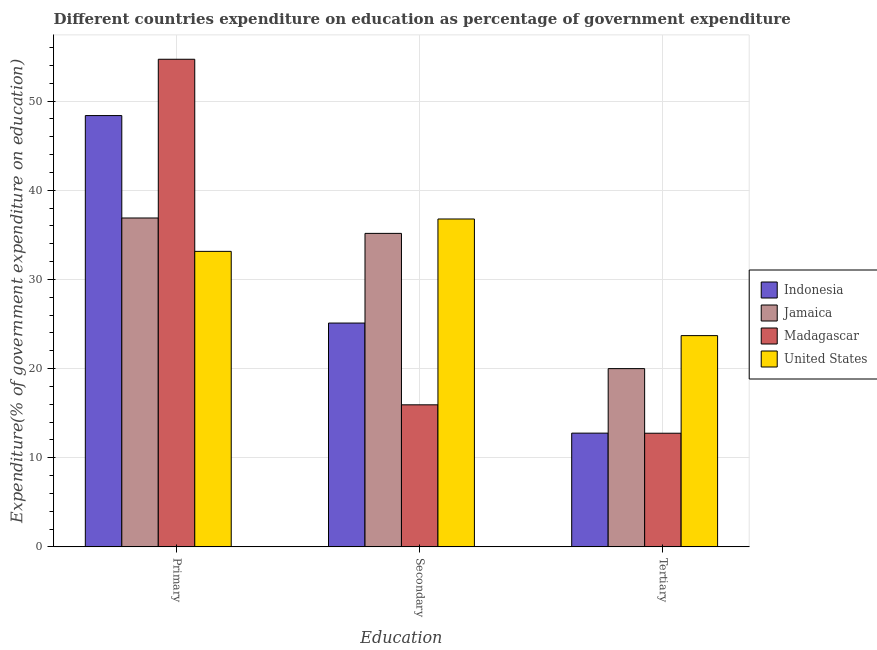How many different coloured bars are there?
Your response must be concise. 4. How many groups of bars are there?
Your answer should be compact. 3. Are the number of bars per tick equal to the number of legend labels?
Provide a succinct answer. Yes. Are the number of bars on each tick of the X-axis equal?
Provide a short and direct response. Yes. How many bars are there on the 1st tick from the left?
Provide a short and direct response. 4. What is the label of the 3rd group of bars from the left?
Offer a terse response. Tertiary. What is the expenditure on tertiary education in Jamaica?
Make the answer very short. 20. Across all countries, what is the maximum expenditure on primary education?
Offer a very short reply. 54.7. Across all countries, what is the minimum expenditure on primary education?
Provide a short and direct response. 33.15. In which country was the expenditure on tertiary education maximum?
Provide a short and direct response. United States. In which country was the expenditure on secondary education minimum?
Make the answer very short. Madagascar. What is the total expenditure on secondary education in the graph?
Ensure brevity in your answer.  112.99. What is the difference between the expenditure on primary education in Indonesia and that in Jamaica?
Your answer should be very brief. 11.49. What is the difference between the expenditure on tertiary education in Madagascar and the expenditure on primary education in United States?
Provide a short and direct response. -20.4. What is the average expenditure on tertiary education per country?
Your answer should be compact. 17.3. What is the difference between the expenditure on primary education and expenditure on secondary education in Indonesia?
Give a very brief answer. 23.28. In how many countries, is the expenditure on tertiary education greater than 22 %?
Offer a very short reply. 1. What is the ratio of the expenditure on primary education in Indonesia to that in United States?
Make the answer very short. 1.46. Is the expenditure on tertiary education in Madagascar less than that in Jamaica?
Offer a terse response. Yes. Is the difference between the expenditure on tertiary education in Jamaica and Madagascar greater than the difference between the expenditure on primary education in Jamaica and Madagascar?
Keep it short and to the point. Yes. What is the difference between the highest and the second highest expenditure on tertiary education?
Keep it short and to the point. 3.7. What is the difference between the highest and the lowest expenditure on primary education?
Your answer should be compact. 21.55. In how many countries, is the expenditure on primary education greater than the average expenditure on primary education taken over all countries?
Provide a short and direct response. 2. Is the sum of the expenditure on secondary education in Madagascar and United States greater than the maximum expenditure on primary education across all countries?
Offer a terse response. No. What does the 1st bar from the right in Secondary represents?
Make the answer very short. United States. Is it the case that in every country, the sum of the expenditure on primary education and expenditure on secondary education is greater than the expenditure on tertiary education?
Make the answer very short. Yes. How many bars are there?
Provide a short and direct response. 12. Are all the bars in the graph horizontal?
Provide a short and direct response. No. Where does the legend appear in the graph?
Your answer should be compact. Center right. How are the legend labels stacked?
Give a very brief answer. Vertical. What is the title of the graph?
Make the answer very short. Different countries expenditure on education as percentage of government expenditure. Does "Low & middle income" appear as one of the legend labels in the graph?
Your answer should be very brief. No. What is the label or title of the X-axis?
Your answer should be very brief. Education. What is the label or title of the Y-axis?
Offer a very short reply. Expenditure(% of government expenditure on education). What is the Expenditure(% of government expenditure on education) of Indonesia in Primary?
Make the answer very short. 48.38. What is the Expenditure(% of government expenditure on education) in Jamaica in Primary?
Your answer should be compact. 36.89. What is the Expenditure(% of government expenditure on education) in Madagascar in Primary?
Your answer should be very brief. 54.7. What is the Expenditure(% of government expenditure on education) of United States in Primary?
Provide a short and direct response. 33.15. What is the Expenditure(% of government expenditure on education) of Indonesia in Secondary?
Make the answer very short. 25.11. What is the Expenditure(% of government expenditure on education) of Jamaica in Secondary?
Keep it short and to the point. 35.17. What is the Expenditure(% of government expenditure on education) of Madagascar in Secondary?
Your answer should be compact. 15.93. What is the Expenditure(% of government expenditure on education) of United States in Secondary?
Make the answer very short. 36.78. What is the Expenditure(% of government expenditure on education) in Indonesia in Tertiary?
Your answer should be compact. 12.76. What is the Expenditure(% of government expenditure on education) of Jamaica in Tertiary?
Ensure brevity in your answer.  20. What is the Expenditure(% of government expenditure on education) of Madagascar in Tertiary?
Provide a succinct answer. 12.75. What is the Expenditure(% of government expenditure on education) in United States in Tertiary?
Make the answer very short. 23.7. Across all Education, what is the maximum Expenditure(% of government expenditure on education) of Indonesia?
Ensure brevity in your answer.  48.38. Across all Education, what is the maximum Expenditure(% of government expenditure on education) of Jamaica?
Give a very brief answer. 36.89. Across all Education, what is the maximum Expenditure(% of government expenditure on education) of Madagascar?
Keep it short and to the point. 54.7. Across all Education, what is the maximum Expenditure(% of government expenditure on education) in United States?
Offer a very short reply. 36.78. Across all Education, what is the minimum Expenditure(% of government expenditure on education) in Indonesia?
Keep it short and to the point. 12.76. Across all Education, what is the minimum Expenditure(% of government expenditure on education) in Jamaica?
Keep it short and to the point. 20. Across all Education, what is the minimum Expenditure(% of government expenditure on education) in Madagascar?
Provide a succinct answer. 12.75. Across all Education, what is the minimum Expenditure(% of government expenditure on education) in United States?
Your response must be concise. 23.7. What is the total Expenditure(% of government expenditure on education) of Indonesia in the graph?
Your response must be concise. 86.25. What is the total Expenditure(% of government expenditure on education) in Jamaica in the graph?
Keep it short and to the point. 92.05. What is the total Expenditure(% of government expenditure on education) of Madagascar in the graph?
Keep it short and to the point. 83.38. What is the total Expenditure(% of government expenditure on education) of United States in the graph?
Keep it short and to the point. 93.63. What is the difference between the Expenditure(% of government expenditure on education) of Indonesia in Primary and that in Secondary?
Provide a short and direct response. 23.28. What is the difference between the Expenditure(% of government expenditure on education) in Jamaica in Primary and that in Secondary?
Your response must be concise. 1.73. What is the difference between the Expenditure(% of government expenditure on education) of Madagascar in Primary and that in Secondary?
Your answer should be compact. 38.77. What is the difference between the Expenditure(% of government expenditure on education) of United States in Primary and that in Secondary?
Ensure brevity in your answer.  -3.63. What is the difference between the Expenditure(% of government expenditure on education) in Indonesia in Primary and that in Tertiary?
Your answer should be compact. 35.63. What is the difference between the Expenditure(% of government expenditure on education) of Jamaica in Primary and that in Tertiary?
Your answer should be very brief. 16.9. What is the difference between the Expenditure(% of government expenditure on education) in Madagascar in Primary and that in Tertiary?
Offer a very short reply. 41.95. What is the difference between the Expenditure(% of government expenditure on education) of United States in Primary and that in Tertiary?
Ensure brevity in your answer.  9.45. What is the difference between the Expenditure(% of government expenditure on education) in Indonesia in Secondary and that in Tertiary?
Your answer should be very brief. 12.35. What is the difference between the Expenditure(% of government expenditure on education) of Jamaica in Secondary and that in Tertiary?
Offer a terse response. 15.17. What is the difference between the Expenditure(% of government expenditure on education) of Madagascar in Secondary and that in Tertiary?
Keep it short and to the point. 3.19. What is the difference between the Expenditure(% of government expenditure on education) of United States in Secondary and that in Tertiary?
Ensure brevity in your answer.  13.08. What is the difference between the Expenditure(% of government expenditure on education) in Indonesia in Primary and the Expenditure(% of government expenditure on education) in Jamaica in Secondary?
Your answer should be very brief. 13.22. What is the difference between the Expenditure(% of government expenditure on education) in Indonesia in Primary and the Expenditure(% of government expenditure on education) in Madagascar in Secondary?
Offer a very short reply. 32.45. What is the difference between the Expenditure(% of government expenditure on education) in Indonesia in Primary and the Expenditure(% of government expenditure on education) in United States in Secondary?
Keep it short and to the point. 11.6. What is the difference between the Expenditure(% of government expenditure on education) of Jamaica in Primary and the Expenditure(% of government expenditure on education) of Madagascar in Secondary?
Offer a terse response. 20.96. What is the difference between the Expenditure(% of government expenditure on education) in Jamaica in Primary and the Expenditure(% of government expenditure on education) in United States in Secondary?
Provide a succinct answer. 0.11. What is the difference between the Expenditure(% of government expenditure on education) in Madagascar in Primary and the Expenditure(% of government expenditure on education) in United States in Secondary?
Your answer should be very brief. 17.92. What is the difference between the Expenditure(% of government expenditure on education) of Indonesia in Primary and the Expenditure(% of government expenditure on education) of Jamaica in Tertiary?
Your answer should be very brief. 28.39. What is the difference between the Expenditure(% of government expenditure on education) of Indonesia in Primary and the Expenditure(% of government expenditure on education) of Madagascar in Tertiary?
Provide a succinct answer. 35.64. What is the difference between the Expenditure(% of government expenditure on education) of Indonesia in Primary and the Expenditure(% of government expenditure on education) of United States in Tertiary?
Your answer should be very brief. 24.69. What is the difference between the Expenditure(% of government expenditure on education) in Jamaica in Primary and the Expenditure(% of government expenditure on education) in Madagascar in Tertiary?
Ensure brevity in your answer.  24.15. What is the difference between the Expenditure(% of government expenditure on education) in Jamaica in Primary and the Expenditure(% of government expenditure on education) in United States in Tertiary?
Give a very brief answer. 13.19. What is the difference between the Expenditure(% of government expenditure on education) of Madagascar in Primary and the Expenditure(% of government expenditure on education) of United States in Tertiary?
Your response must be concise. 31. What is the difference between the Expenditure(% of government expenditure on education) in Indonesia in Secondary and the Expenditure(% of government expenditure on education) in Jamaica in Tertiary?
Offer a terse response. 5.11. What is the difference between the Expenditure(% of government expenditure on education) in Indonesia in Secondary and the Expenditure(% of government expenditure on education) in Madagascar in Tertiary?
Offer a very short reply. 12.36. What is the difference between the Expenditure(% of government expenditure on education) of Indonesia in Secondary and the Expenditure(% of government expenditure on education) of United States in Tertiary?
Give a very brief answer. 1.41. What is the difference between the Expenditure(% of government expenditure on education) of Jamaica in Secondary and the Expenditure(% of government expenditure on education) of Madagascar in Tertiary?
Give a very brief answer. 22.42. What is the difference between the Expenditure(% of government expenditure on education) of Jamaica in Secondary and the Expenditure(% of government expenditure on education) of United States in Tertiary?
Offer a very short reply. 11.47. What is the difference between the Expenditure(% of government expenditure on education) of Madagascar in Secondary and the Expenditure(% of government expenditure on education) of United States in Tertiary?
Your answer should be very brief. -7.76. What is the average Expenditure(% of government expenditure on education) in Indonesia per Education?
Keep it short and to the point. 28.75. What is the average Expenditure(% of government expenditure on education) in Jamaica per Education?
Keep it short and to the point. 30.68. What is the average Expenditure(% of government expenditure on education) in Madagascar per Education?
Ensure brevity in your answer.  27.79. What is the average Expenditure(% of government expenditure on education) in United States per Education?
Keep it short and to the point. 31.21. What is the difference between the Expenditure(% of government expenditure on education) of Indonesia and Expenditure(% of government expenditure on education) of Jamaica in Primary?
Provide a succinct answer. 11.49. What is the difference between the Expenditure(% of government expenditure on education) of Indonesia and Expenditure(% of government expenditure on education) of Madagascar in Primary?
Give a very brief answer. -6.32. What is the difference between the Expenditure(% of government expenditure on education) of Indonesia and Expenditure(% of government expenditure on education) of United States in Primary?
Provide a short and direct response. 15.23. What is the difference between the Expenditure(% of government expenditure on education) of Jamaica and Expenditure(% of government expenditure on education) of Madagascar in Primary?
Give a very brief answer. -17.81. What is the difference between the Expenditure(% of government expenditure on education) in Jamaica and Expenditure(% of government expenditure on education) in United States in Primary?
Provide a short and direct response. 3.74. What is the difference between the Expenditure(% of government expenditure on education) in Madagascar and Expenditure(% of government expenditure on education) in United States in Primary?
Give a very brief answer. 21.55. What is the difference between the Expenditure(% of government expenditure on education) of Indonesia and Expenditure(% of government expenditure on education) of Jamaica in Secondary?
Offer a very short reply. -10.06. What is the difference between the Expenditure(% of government expenditure on education) in Indonesia and Expenditure(% of government expenditure on education) in Madagascar in Secondary?
Your response must be concise. 9.17. What is the difference between the Expenditure(% of government expenditure on education) in Indonesia and Expenditure(% of government expenditure on education) in United States in Secondary?
Ensure brevity in your answer.  -11.67. What is the difference between the Expenditure(% of government expenditure on education) of Jamaica and Expenditure(% of government expenditure on education) of Madagascar in Secondary?
Your response must be concise. 19.23. What is the difference between the Expenditure(% of government expenditure on education) of Jamaica and Expenditure(% of government expenditure on education) of United States in Secondary?
Offer a very short reply. -1.61. What is the difference between the Expenditure(% of government expenditure on education) of Madagascar and Expenditure(% of government expenditure on education) of United States in Secondary?
Offer a terse response. -20.85. What is the difference between the Expenditure(% of government expenditure on education) in Indonesia and Expenditure(% of government expenditure on education) in Jamaica in Tertiary?
Provide a succinct answer. -7.24. What is the difference between the Expenditure(% of government expenditure on education) of Indonesia and Expenditure(% of government expenditure on education) of Madagascar in Tertiary?
Provide a succinct answer. 0.01. What is the difference between the Expenditure(% of government expenditure on education) of Indonesia and Expenditure(% of government expenditure on education) of United States in Tertiary?
Offer a terse response. -10.94. What is the difference between the Expenditure(% of government expenditure on education) of Jamaica and Expenditure(% of government expenditure on education) of Madagascar in Tertiary?
Offer a very short reply. 7.25. What is the difference between the Expenditure(% of government expenditure on education) of Jamaica and Expenditure(% of government expenditure on education) of United States in Tertiary?
Offer a very short reply. -3.7. What is the difference between the Expenditure(% of government expenditure on education) of Madagascar and Expenditure(% of government expenditure on education) of United States in Tertiary?
Give a very brief answer. -10.95. What is the ratio of the Expenditure(% of government expenditure on education) in Indonesia in Primary to that in Secondary?
Provide a succinct answer. 1.93. What is the ratio of the Expenditure(% of government expenditure on education) in Jamaica in Primary to that in Secondary?
Keep it short and to the point. 1.05. What is the ratio of the Expenditure(% of government expenditure on education) in Madagascar in Primary to that in Secondary?
Provide a succinct answer. 3.43. What is the ratio of the Expenditure(% of government expenditure on education) in United States in Primary to that in Secondary?
Provide a succinct answer. 0.9. What is the ratio of the Expenditure(% of government expenditure on education) in Indonesia in Primary to that in Tertiary?
Give a very brief answer. 3.79. What is the ratio of the Expenditure(% of government expenditure on education) of Jamaica in Primary to that in Tertiary?
Your answer should be compact. 1.84. What is the ratio of the Expenditure(% of government expenditure on education) in Madagascar in Primary to that in Tertiary?
Offer a terse response. 4.29. What is the ratio of the Expenditure(% of government expenditure on education) in United States in Primary to that in Tertiary?
Provide a short and direct response. 1.4. What is the ratio of the Expenditure(% of government expenditure on education) of Indonesia in Secondary to that in Tertiary?
Offer a very short reply. 1.97. What is the ratio of the Expenditure(% of government expenditure on education) of Jamaica in Secondary to that in Tertiary?
Your response must be concise. 1.76. What is the ratio of the Expenditure(% of government expenditure on education) in United States in Secondary to that in Tertiary?
Provide a short and direct response. 1.55. What is the difference between the highest and the second highest Expenditure(% of government expenditure on education) of Indonesia?
Give a very brief answer. 23.28. What is the difference between the highest and the second highest Expenditure(% of government expenditure on education) in Jamaica?
Make the answer very short. 1.73. What is the difference between the highest and the second highest Expenditure(% of government expenditure on education) in Madagascar?
Keep it short and to the point. 38.77. What is the difference between the highest and the second highest Expenditure(% of government expenditure on education) of United States?
Ensure brevity in your answer.  3.63. What is the difference between the highest and the lowest Expenditure(% of government expenditure on education) of Indonesia?
Give a very brief answer. 35.63. What is the difference between the highest and the lowest Expenditure(% of government expenditure on education) in Jamaica?
Give a very brief answer. 16.9. What is the difference between the highest and the lowest Expenditure(% of government expenditure on education) of Madagascar?
Provide a short and direct response. 41.95. What is the difference between the highest and the lowest Expenditure(% of government expenditure on education) in United States?
Provide a succinct answer. 13.08. 